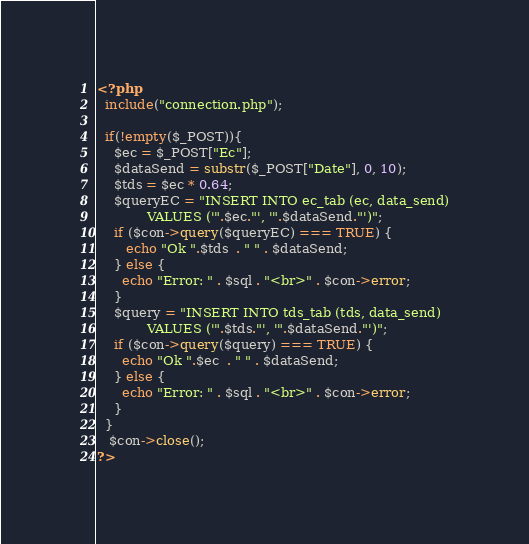<code> <loc_0><loc_0><loc_500><loc_500><_PHP_><?php
  include("connection.php");

  if(!empty($_POST)){
    $ec = $_POST["Ec"];
    $dataSend = substr($_POST["Date"], 0, 10);
    $tds = $ec * 0.64;
    $queryEC = "INSERT INTO ec_tab (ec, data_send)
            VALUES ('".$ec."', '".$dataSend."')";
    if ($con->query($queryEC) === TRUE) {
       echo "Ok ".$tds  . " " . $dataSend;
    } else {
      echo "Error: " . $sql . "<br>" . $con->error;
    }
    $query = "INSERT INTO tds_tab (tds, data_send)
            VALUES ('".$tds."', '".$dataSend."')";
    if ($con->query($query) === TRUE) {
      echo "Ok ".$ec  . " " . $dataSend;
    } else {
      echo "Error: " . $sql . "<br>" . $con->error;
    }
  }
   $con->close();
?></code> 